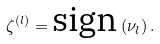<formula> <loc_0><loc_0><loc_500><loc_500>\zeta ^ { \left ( l \right ) } = \text {sign} \left ( \nu _ { l } \right ) .</formula> 